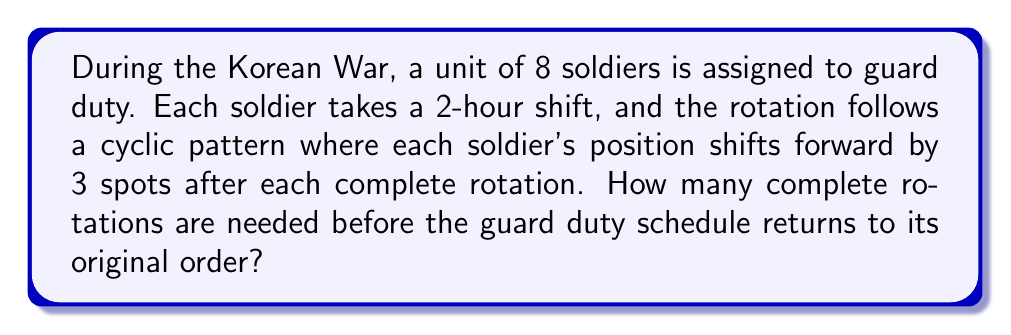Teach me how to tackle this problem. Let's approach this step-by-step:

1) First, we need to understand what's happening mathematically. This is a permutation of 8 elements, where each element (soldier) is moved 3 positions forward in each rotation.

2) In mathematical terms, this is a cyclic permutation. We can represent it as:
   $$(1 \to 4 \to 7 \to 2 \to 5 \to 8 \to 3 \to 6 \to 1)$$

3) To find how many rotations are needed to return to the original order, we need to find the order of this permutation. In group theory, the order of an element is the smallest positive integer $n$ such that $a^n = e$, where $e$ is the identity element.

4) In this case, we're looking for how many times we need to apply this permutation to get back to the identity permutation (original order).

5) We can calculate this using the concept of modular arithmetic. After each rotation, a soldier in position $i$ moves to position $(i + 3) \mod 8$.

6) Let's follow soldier 1:
   Rotation 1: $1 \to 4$
   Rotation 2: $4 \to 7$
   Rotation 3: $7 \to 2$
   Rotation 4: $2 \to 5$
   Rotation 5: $5 \to 8$
   Rotation 6: $8 \to 3$
   Rotation 7: $3 \to 6$
   Rotation 8: $6 \to 1$

7) After 8 rotations, soldier 1 is back in position 1. This means the order of the permutation is 8.

8) We can verify this mathematically:
   $$(3 \cdot 8) \mod 8 = 24 \mod 8 = 0$$
   This confirms that after 8 rotations, each soldier has moved a multiple of 8 positions, putting them back in their original spot.
Answer: 8 complete rotations are needed before the guard duty schedule returns to its original order. 